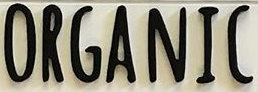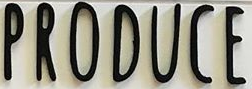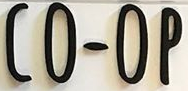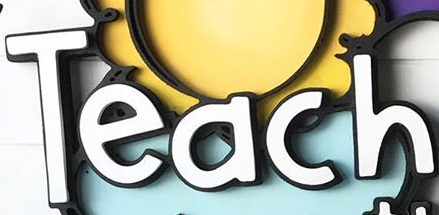Identify the words shown in these images in order, separated by a semicolon. ORGANIC; PRODUCE; CO-OP; Teach 